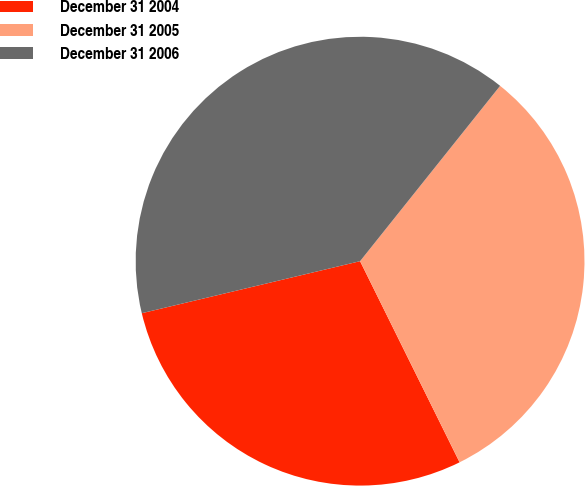Convert chart to OTSL. <chart><loc_0><loc_0><loc_500><loc_500><pie_chart><fcel>December 31 2004<fcel>December 31 2005<fcel>December 31 2006<nl><fcel>28.59%<fcel>31.96%<fcel>39.45%<nl></chart> 